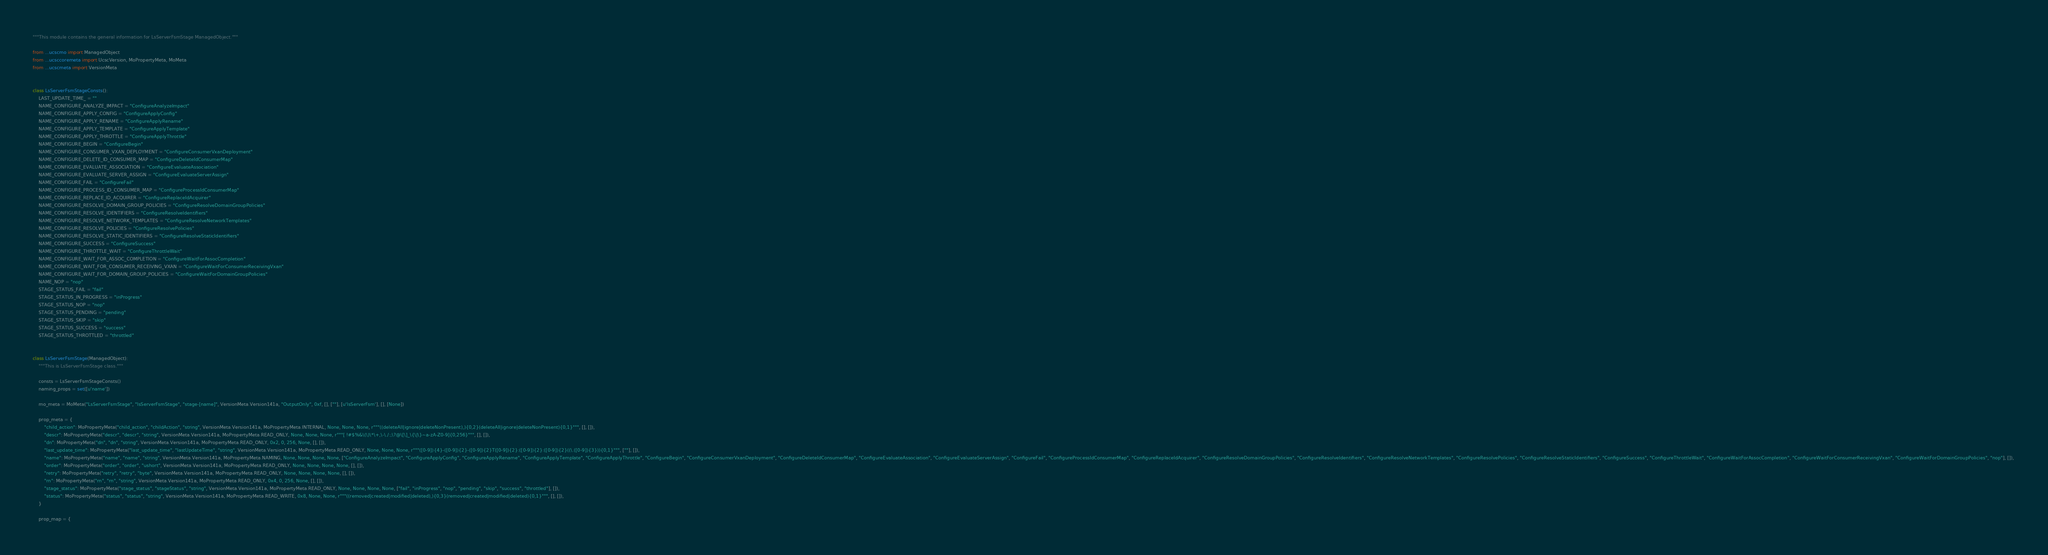Convert code to text. <code><loc_0><loc_0><loc_500><loc_500><_Python_>"""This module contains the general information for LsServerFsmStage ManagedObject."""

from ...ucscmo import ManagedObject
from ...ucsccoremeta import UcscVersion, MoPropertyMeta, MoMeta
from ...ucscmeta import VersionMeta


class LsServerFsmStageConsts():
    LAST_UPDATE_TIME_ = ""
    NAME_CONFIGURE_ANALYZE_IMPACT = "ConfigureAnalyzeImpact"
    NAME_CONFIGURE_APPLY_CONFIG = "ConfigureApplyConfig"
    NAME_CONFIGURE_APPLY_RENAME = "ConfigureApplyRename"
    NAME_CONFIGURE_APPLY_TEMPLATE = "ConfigureApplyTemplate"
    NAME_CONFIGURE_APPLY_THROTTLE = "ConfigureApplyThrottle"
    NAME_CONFIGURE_BEGIN = "ConfigureBegin"
    NAME_CONFIGURE_CONSUMER_VXAN_DEPLOYMENT = "ConfigureConsumerVxanDeployment"
    NAME_CONFIGURE_DELETE_ID_CONSUMER_MAP = "ConfigureDeleteIdConsumerMap"
    NAME_CONFIGURE_EVALUATE_ASSOCIATION = "ConfigureEvaluateAssociation"
    NAME_CONFIGURE_EVALUATE_SERVER_ASSIGN = "ConfigureEvaluateServerAssign"
    NAME_CONFIGURE_FAIL = "ConfigureFail"
    NAME_CONFIGURE_PROCESS_ID_CONSUMER_MAP = "ConfigureProcessIdConsumerMap"
    NAME_CONFIGURE_REPLACE_ID_ACQUIRER = "ConfigureReplaceIdAcquirer"
    NAME_CONFIGURE_RESOLVE_DOMAIN_GROUP_POLICIES = "ConfigureResolveDomainGroupPolicies"
    NAME_CONFIGURE_RESOLVE_IDENTIFIERS = "ConfigureResolveIdentifiers"
    NAME_CONFIGURE_RESOLVE_NETWORK_TEMPLATES = "ConfigureResolveNetworkTemplates"
    NAME_CONFIGURE_RESOLVE_POLICIES = "ConfigureResolvePolicies"
    NAME_CONFIGURE_RESOLVE_STATIC_IDENTIFIERS = "ConfigureResolveStaticIdentifiers"
    NAME_CONFIGURE_SUCCESS = "ConfigureSuccess"
    NAME_CONFIGURE_THROTTLE_WAIT = "ConfigureThrottleWait"
    NAME_CONFIGURE_WAIT_FOR_ASSOC_COMPLETION = "ConfigureWaitForAssocCompletion"
    NAME_CONFIGURE_WAIT_FOR_CONSUMER_RECEIVING_VXAN = "ConfigureWaitForConsumerReceivingVxan"
    NAME_CONFIGURE_WAIT_FOR_DOMAIN_GROUP_POLICIES = "ConfigureWaitForDomainGroupPolicies"
    NAME_NOP = "nop"
    STAGE_STATUS_FAIL = "fail"
    STAGE_STATUS_IN_PROGRESS = "inProgress"
    STAGE_STATUS_NOP = "nop"
    STAGE_STATUS_PENDING = "pending"
    STAGE_STATUS_SKIP = "skip"
    STAGE_STATUS_SUCCESS = "success"
    STAGE_STATUS_THROTTLED = "throttled"


class LsServerFsmStage(ManagedObject):
    """This is LsServerFsmStage class."""

    consts = LsServerFsmStageConsts()
    naming_props = set([u'name'])

    mo_meta = MoMeta("LsServerFsmStage", "lsServerFsmStage", "stage-[name]", VersionMeta.Version141a, "OutputOnly", 0xf, [], [""], [u'lsServerFsm'], [], [None])

    prop_meta = {
        "child_action": MoPropertyMeta("child_action", "childAction", "string", VersionMeta.Version141a, MoPropertyMeta.INTERNAL, None, None, None, r"""((deleteAll|ignore|deleteNonPresent),){0,2}(deleteAll|ignore|deleteNonPresent){0,1}""", [], []), 
        "descr": MoPropertyMeta("descr", "descr", "string", VersionMeta.Version141a, MoPropertyMeta.READ_ONLY, None, None, None, r"""[ !#$%&\(\)\*\+,\-\./:;\?@\[\]_\{\|\}~a-zA-Z0-9]{0,256}""", [], []), 
        "dn": MoPropertyMeta("dn", "dn", "string", VersionMeta.Version141a, MoPropertyMeta.READ_ONLY, 0x2, 0, 256, None, [], []), 
        "last_update_time": MoPropertyMeta("last_update_time", "lastUpdateTime", "string", VersionMeta.Version141a, MoPropertyMeta.READ_ONLY, None, None, None, r"""([0-9]){4}-([0-9]){2}-([0-9]){2}T([0-9]){2}:([0-9]){2}:([0-9]){2}((\.([0-9]){3})){0,1}""", [""], []), 
        "name": MoPropertyMeta("name", "name", "string", VersionMeta.Version141a, MoPropertyMeta.NAMING, None, None, None, None, ["ConfigureAnalyzeImpact", "ConfigureApplyConfig", "ConfigureApplyRename", "ConfigureApplyTemplate", "ConfigureApplyThrottle", "ConfigureBegin", "ConfigureConsumerVxanDeployment", "ConfigureDeleteIdConsumerMap", "ConfigureEvaluateAssociation", "ConfigureEvaluateServerAssign", "ConfigureFail", "ConfigureProcessIdConsumerMap", "ConfigureReplaceIdAcquirer", "ConfigureResolveDomainGroupPolicies", "ConfigureResolveIdentifiers", "ConfigureResolveNetworkTemplates", "ConfigureResolvePolicies", "ConfigureResolveStaticIdentifiers", "ConfigureSuccess", "ConfigureThrottleWait", "ConfigureWaitForAssocCompletion", "ConfigureWaitForConsumerReceivingVxan", "ConfigureWaitForDomainGroupPolicies", "nop"], []), 
        "order": MoPropertyMeta("order", "order", "ushort", VersionMeta.Version141a, MoPropertyMeta.READ_ONLY, None, None, None, None, [], []), 
        "retry": MoPropertyMeta("retry", "retry", "byte", VersionMeta.Version141a, MoPropertyMeta.READ_ONLY, None, None, None, None, [], []), 
        "rn": MoPropertyMeta("rn", "rn", "string", VersionMeta.Version141a, MoPropertyMeta.READ_ONLY, 0x4, 0, 256, None, [], []), 
        "stage_status": MoPropertyMeta("stage_status", "stageStatus", "string", VersionMeta.Version141a, MoPropertyMeta.READ_ONLY, None, None, None, None, ["fail", "inProgress", "nop", "pending", "skip", "success", "throttled"], []), 
        "status": MoPropertyMeta("status", "status", "string", VersionMeta.Version141a, MoPropertyMeta.READ_WRITE, 0x8, None, None, r"""((removed|created|modified|deleted),){0,3}(removed|created|modified|deleted){0,1}""", [], []), 
    }

    prop_map = {</code> 